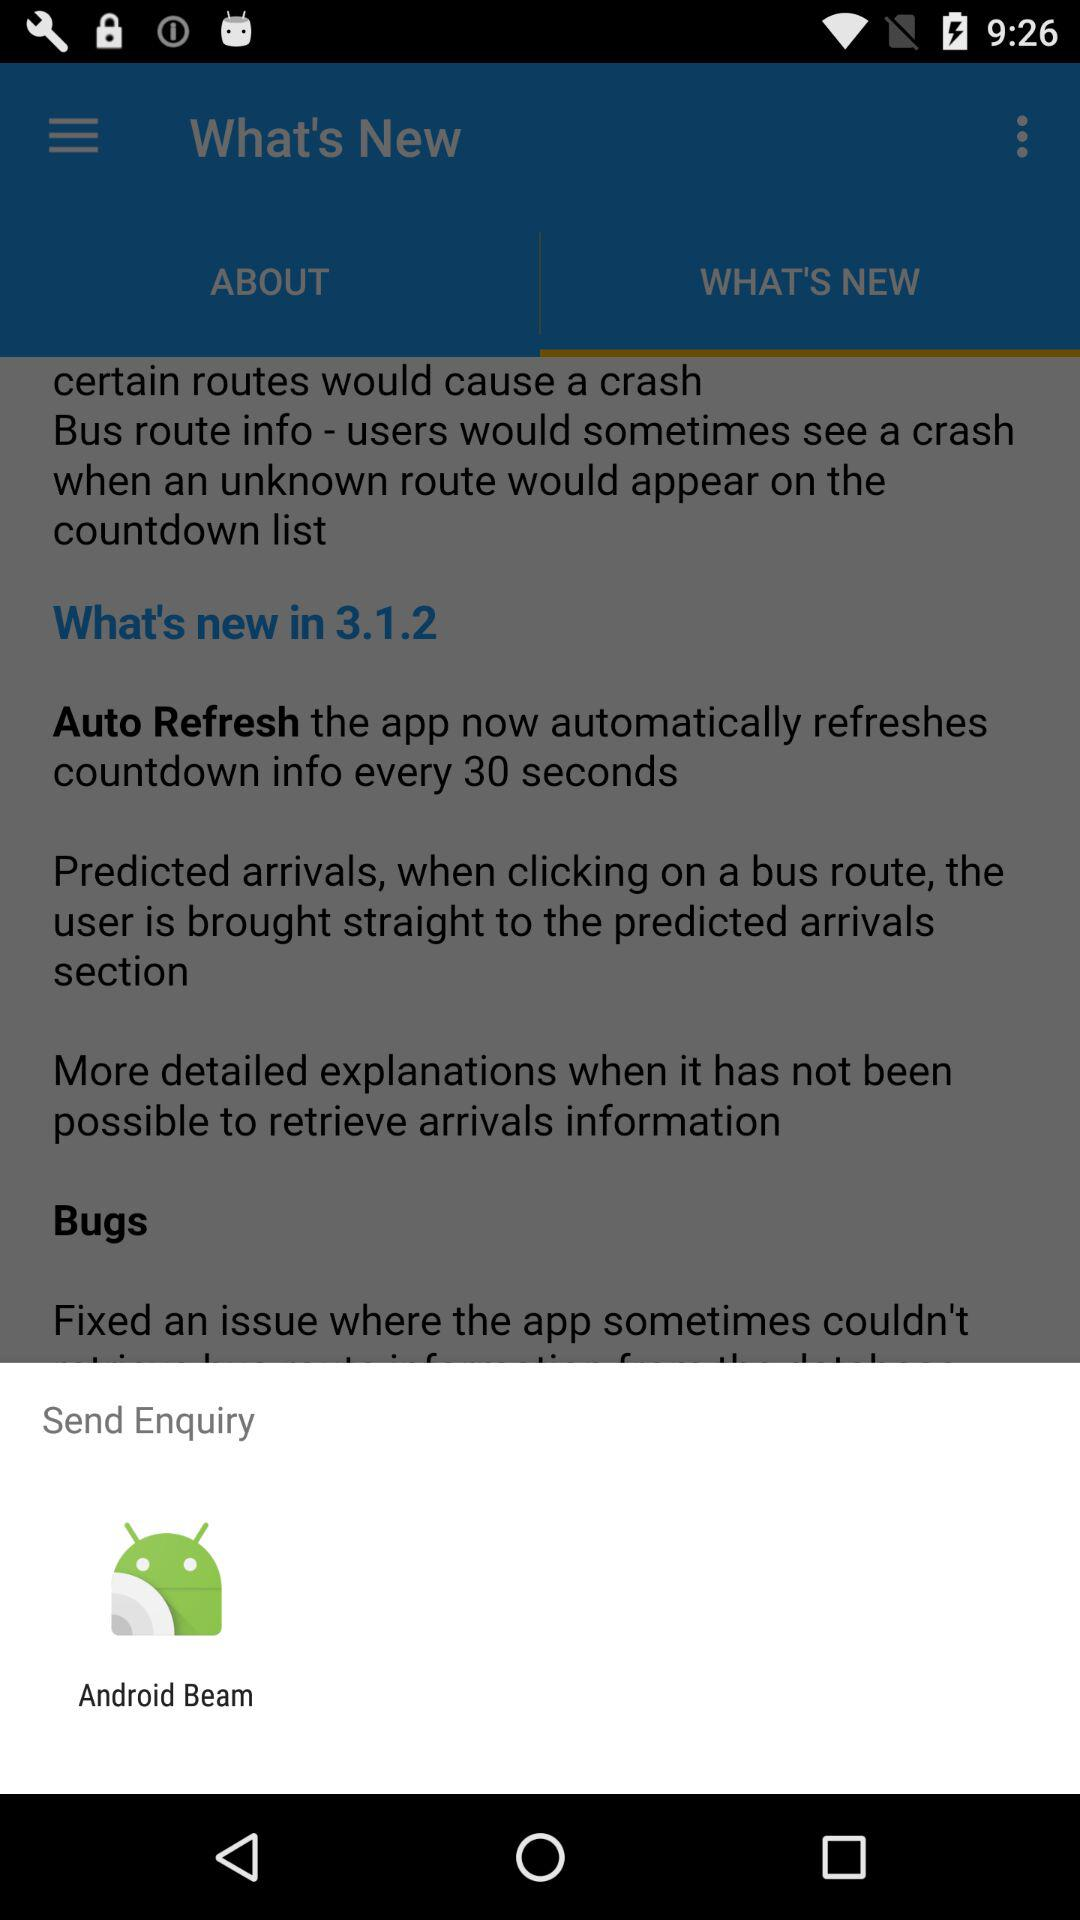Through what application can we send an enquiry? The application is "Android Beam". 